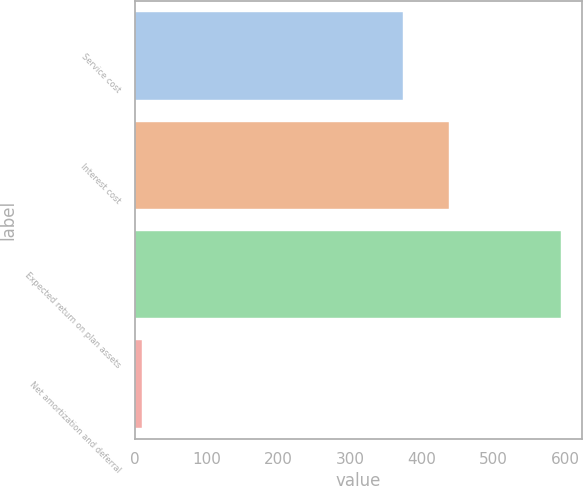Convert chart. <chart><loc_0><loc_0><loc_500><loc_500><bar_chart><fcel>Service cost<fcel>Interest cost<fcel>Expected return on plan assets<fcel>Net amortization and deferral<nl><fcel>374<fcel>438<fcel>594<fcel>10<nl></chart> 